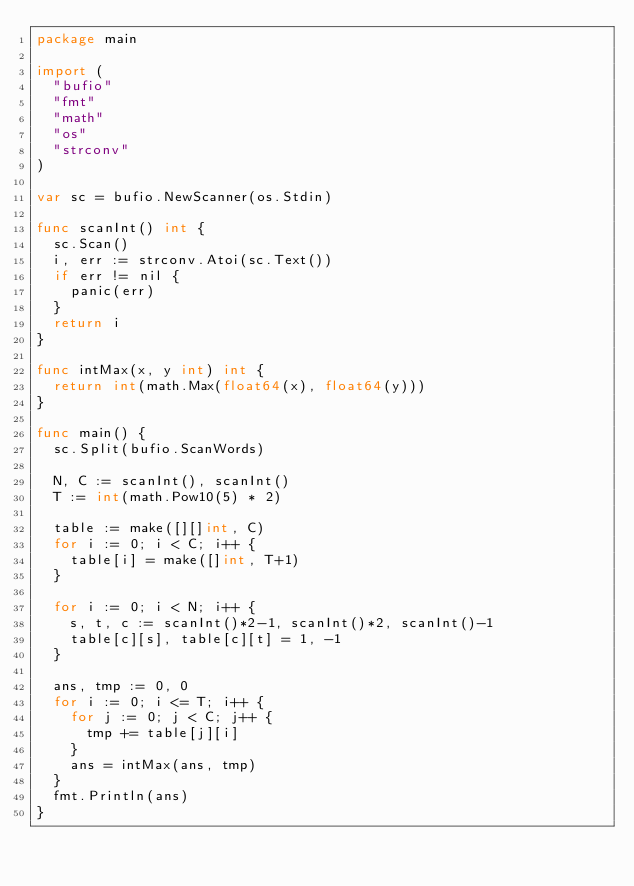<code> <loc_0><loc_0><loc_500><loc_500><_Go_>package main

import (
	"bufio"
	"fmt"
	"math"
	"os"
	"strconv"
)

var sc = bufio.NewScanner(os.Stdin)

func scanInt() int {
	sc.Scan()
	i, err := strconv.Atoi(sc.Text())
	if err != nil {
		panic(err)
	}
	return i
}

func intMax(x, y int) int {
	return int(math.Max(float64(x), float64(y)))
}

func main() {
	sc.Split(bufio.ScanWords)

	N, C := scanInt(), scanInt()
	T := int(math.Pow10(5) * 2)

	table := make([][]int, C)
	for i := 0; i < C; i++ {
		table[i] = make([]int, T+1)
	}

	for i := 0; i < N; i++ {
		s, t, c := scanInt()*2-1, scanInt()*2, scanInt()-1
		table[c][s], table[c][t] = 1, -1
	}

	ans, tmp := 0, 0
	for i := 0; i <= T; i++ {
		for j := 0; j < C; j++ {
			tmp += table[j][i]
		}
		ans = intMax(ans, tmp)
	}
	fmt.Println(ans)
}
</code> 